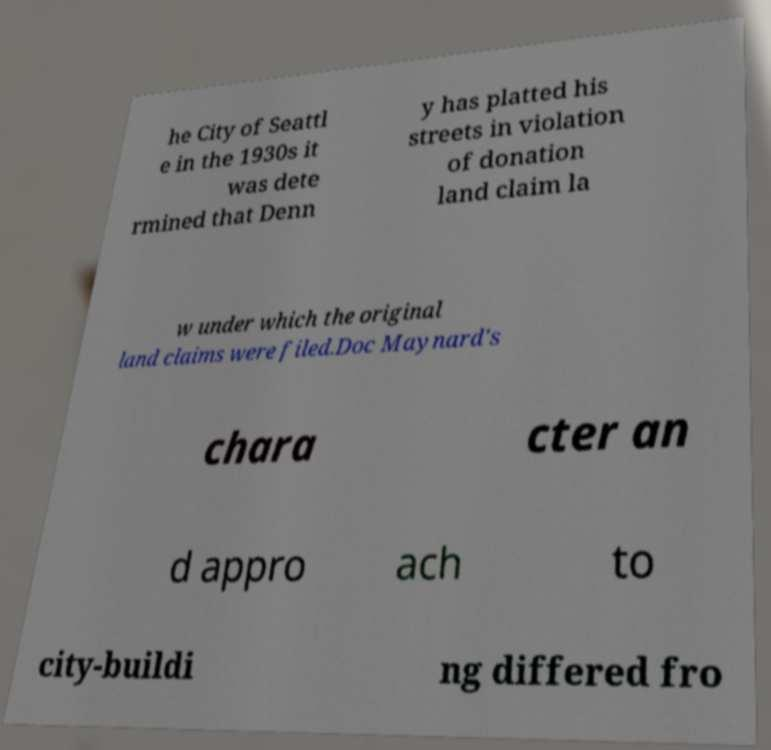What messages or text are displayed in this image? I need them in a readable, typed format. he City of Seattl e in the 1930s it was dete rmined that Denn y has platted his streets in violation of donation land claim la w under which the original land claims were filed.Doc Maynard's chara cter an d appro ach to city-buildi ng differed fro 